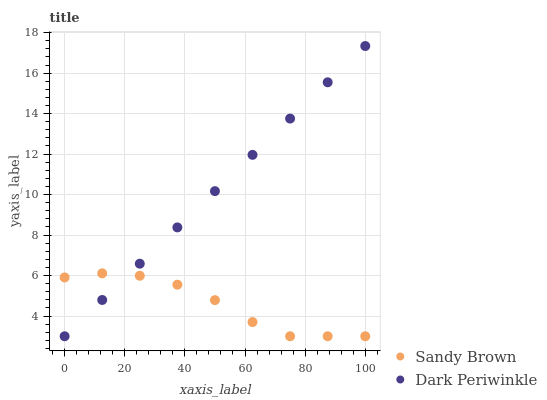Does Sandy Brown have the minimum area under the curve?
Answer yes or no. Yes. Does Dark Periwinkle have the maximum area under the curve?
Answer yes or no. Yes. Does Dark Periwinkle have the minimum area under the curve?
Answer yes or no. No. Is Dark Periwinkle the smoothest?
Answer yes or no. Yes. Is Sandy Brown the roughest?
Answer yes or no. Yes. Is Dark Periwinkle the roughest?
Answer yes or no. No. Does Sandy Brown have the lowest value?
Answer yes or no. Yes. Does Dark Periwinkle have the highest value?
Answer yes or no. Yes. Does Sandy Brown intersect Dark Periwinkle?
Answer yes or no. Yes. Is Sandy Brown less than Dark Periwinkle?
Answer yes or no. No. Is Sandy Brown greater than Dark Periwinkle?
Answer yes or no. No. 